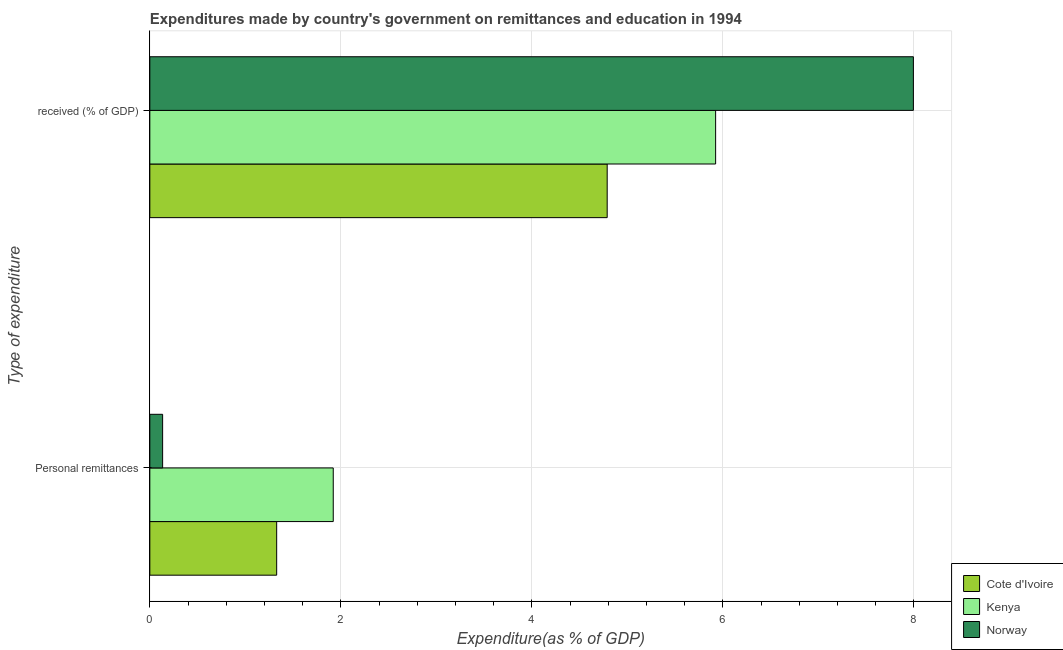How many different coloured bars are there?
Provide a succinct answer. 3. How many groups of bars are there?
Your answer should be very brief. 2. Are the number of bars per tick equal to the number of legend labels?
Make the answer very short. Yes. How many bars are there on the 2nd tick from the top?
Offer a very short reply. 3. How many bars are there on the 1st tick from the bottom?
Make the answer very short. 3. What is the label of the 1st group of bars from the top?
Provide a short and direct response.  received (% of GDP). What is the expenditure in personal remittances in Cote d'Ivoire?
Give a very brief answer. 1.33. Across all countries, what is the maximum expenditure in personal remittances?
Offer a very short reply. 1.92. Across all countries, what is the minimum expenditure in personal remittances?
Give a very brief answer. 0.13. In which country was the expenditure in personal remittances minimum?
Your answer should be compact. Norway. What is the total expenditure in education in the graph?
Your response must be concise. 18.71. What is the difference between the expenditure in personal remittances in Norway and that in Cote d'Ivoire?
Keep it short and to the point. -1.19. What is the difference between the expenditure in education in Kenya and the expenditure in personal remittances in Norway?
Your response must be concise. 5.79. What is the average expenditure in personal remittances per country?
Keep it short and to the point. 1.13. What is the difference between the expenditure in education and expenditure in personal remittances in Kenya?
Give a very brief answer. 4. What is the ratio of the expenditure in personal remittances in Cote d'Ivoire to that in Kenya?
Give a very brief answer. 0.69. Is the expenditure in personal remittances in Norway less than that in Cote d'Ivoire?
Ensure brevity in your answer.  Yes. What does the 3rd bar from the top in Personal remittances represents?
Make the answer very short. Cote d'Ivoire. What does the 2nd bar from the bottom in  received (% of GDP) represents?
Offer a terse response. Kenya. How many countries are there in the graph?
Keep it short and to the point. 3. Are the values on the major ticks of X-axis written in scientific E-notation?
Provide a succinct answer. No. Does the graph contain grids?
Offer a very short reply. Yes. Where does the legend appear in the graph?
Give a very brief answer. Bottom right. What is the title of the graph?
Ensure brevity in your answer.  Expenditures made by country's government on remittances and education in 1994. Does "Romania" appear as one of the legend labels in the graph?
Provide a succinct answer. No. What is the label or title of the X-axis?
Keep it short and to the point. Expenditure(as % of GDP). What is the label or title of the Y-axis?
Offer a terse response. Type of expenditure. What is the Expenditure(as % of GDP) in Cote d'Ivoire in Personal remittances?
Your response must be concise. 1.33. What is the Expenditure(as % of GDP) of Kenya in Personal remittances?
Give a very brief answer. 1.92. What is the Expenditure(as % of GDP) in Norway in Personal remittances?
Ensure brevity in your answer.  0.13. What is the Expenditure(as % of GDP) in Cote d'Ivoire in  received (% of GDP)?
Make the answer very short. 4.79. What is the Expenditure(as % of GDP) in Kenya in  received (% of GDP)?
Provide a short and direct response. 5.92. What is the Expenditure(as % of GDP) in Norway in  received (% of GDP)?
Your response must be concise. 7.99. Across all Type of expenditure, what is the maximum Expenditure(as % of GDP) of Cote d'Ivoire?
Provide a short and direct response. 4.79. Across all Type of expenditure, what is the maximum Expenditure(as % of GDP) in Kenya?
Your response must be concise. 5.92. Across all Type of expenditure, what is the maximum Expenditure(as % of GDP) of Norway?
Give a very brief answer. 7.99. Across all Type of expenditure, what is the minimum Expenditure(as % of GDP) of Cote d'Ivoire?
Make the answer very short. 1.33. Across all Type of expenditure, what is the minimum Expenditure(as % of GDP) of Kenya?
Your response must be concise. 1.92. Across all Type of expenditure, what is the minimum Expenditure(as % of GDP) of Norway?
Your response must be concise. 0.13. What is the total Expenditure(as % of GDP) of Cote d'Ivoire in the graph?
Keep it short and to the point. 6.12. What is the total Expenditure(as % of GDP) of Kenya in the graph?
Give a very brief answer. 7.84. What is the total Expenditure(as % of GDP) in Norway in the graph?
Make the answer very short. 8.13. What is the difference between the Expenditure(as % of GDP) in Cote d'Ivoire in Personal remittances and that in  received (% of GDP)?
Ensure brevity in your answer.  -3.46. What is the difference between the Expenditure(as % of GDP) of Kenya in Personal remittances and that in  received (% of GDP)?
Make the answer very short. -4. What is the difference between the Expenditure(as % of GDP) in Norway in Personal remittances and that in  received (% of GDP)?
Offer a terse response. -7.86. What is the difference between the Expenditure(as % of GDP) in Cote d'Ivoire in Personal remittances and the Expenditure(as % of GDP) in Kenya in  received (% of GDP)?
Provide a short and direct response. -4.6. What is the difference between the Expenditure(as % of GDP) in Cote d'Ivoire in Personal remittances and the Expenditure(as % of GDP) in Norway in  received (% of GDP)?
Your answer should be very brief. -6.67. What is the difference between the Expenditure(as % of GDP) of Kenya in Personal remittances and the Expenditure(as % of GDP) of Norway in  received (% of GDP)?
Provide a short and direct response. -6.07. What is the average Expenditure(as % of GDP) in Cote d'Ivoire per Type of expenditure?
Ensure brevity in your answer.  3.06. What is the average Expenditure(as % of GDP) of Kenya per Type of expenditure?
Offer a terse response. 3.92. What is the average Expenditure(as % of GDP) in Norway per Type of expenditure?
Provide a succinct answer. 4.06. What is the difference between the Expenditure(as % of GDP) in Cote d'Ivoire and Expenditure(as % of GDP) in Kenya in Personal remittances?
Your response must be concise. -0.59. What is the difference between the Expenditure(as % of GDP) in Cote d'Ivoire and Expenditure(as % of GDP) in Norway in Personal remittances?
Ensure brevity in your answer.  1.19. What is the difference between the Expenditure(as % of GDP) in Kenya and Expenditure(as % of GDP) in Norway in Personal remittances?
Provide a short and direct response. 1.79. What is the difference between the Expenditure(as % of GDP) of Cote d'Ivoire and Expenditure(as % of GDP) of Kenya in  received (% of GDP)?
Offer a very short reply. -1.14. What is the difference between the Expenditure(as % of GDP) in Cote d'Ivoire and Expenditure(as % of GDP) in Norway in  received (% of GDP)?
Ensure brevity in your answer.  -3.21. What is the difference between the Expenditure(as % of GDP) of Kenya and Expenditure(as % of GDP) of Norway in  received (% of GDP)?
Give a very brief answer. -2.07. What is the ratio of the Expenditure(as % of GDP) in Cote d'Ivoire in Personal remittances to that in  received (% of GDP)?
Ensure brevity in your answer.  0.28. What is the ratio of the Expenditure(as % of GDP) in Kenya in Personal remittances to that in  received (% of GDP)?
Provide a short and direct response. 0.32. What is the ratio of the Expenditure(as % of GDP) of Norway in Personal remittances to that in  received (% of GDP)?
Your answer should be very brief. 0.02. What is the difference between the highest and the second highest Expenditure(as % of GDP) of Cote d'Ivoire?
Keep it short and to the point. 3.46. What is the difference between the highest and the second highest Expenditure(as % of GDP) of Kenya?
Your answer should be compact. 4. What is the difference between the highest and the second highest Expenditure(as % of GDP) in Norway?
Your answer should be compact. 7.86. What is the difference between the highest and the lowest Expenditure(as % of GDP) in Cote d'Ivoire?
Offer a very short reply. 3.46. What is the difference between the highest and the lowest Expenditure(as % of GDP) in Kenya?
Make the answer very short. 4. What is the difference between the highest and the lowest Expenditure(as % of GDP) of Norway?
Offer a very short reply. 7.86. 